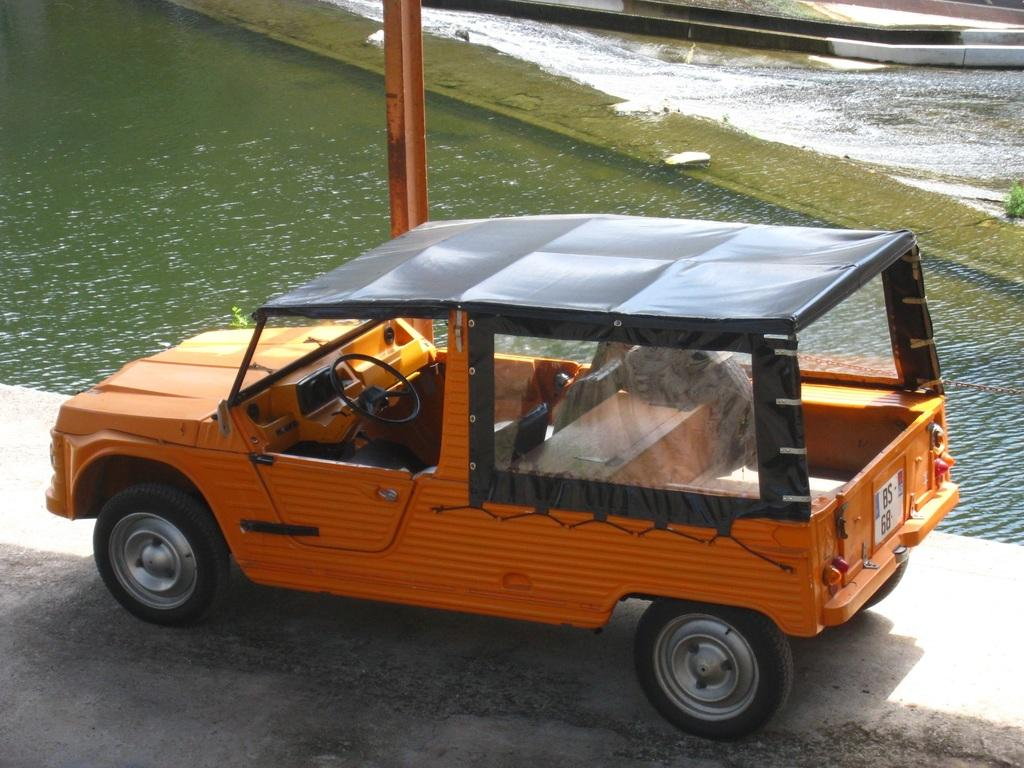What is the main subject of the picture? There is a vehicle in the picture. What can be seen in the background of the picture? There is water and a pole visible in the background of the picture. What is the texture of the town in the image? There is no town present in the image, so it is not possible to determine the texture of a town. 